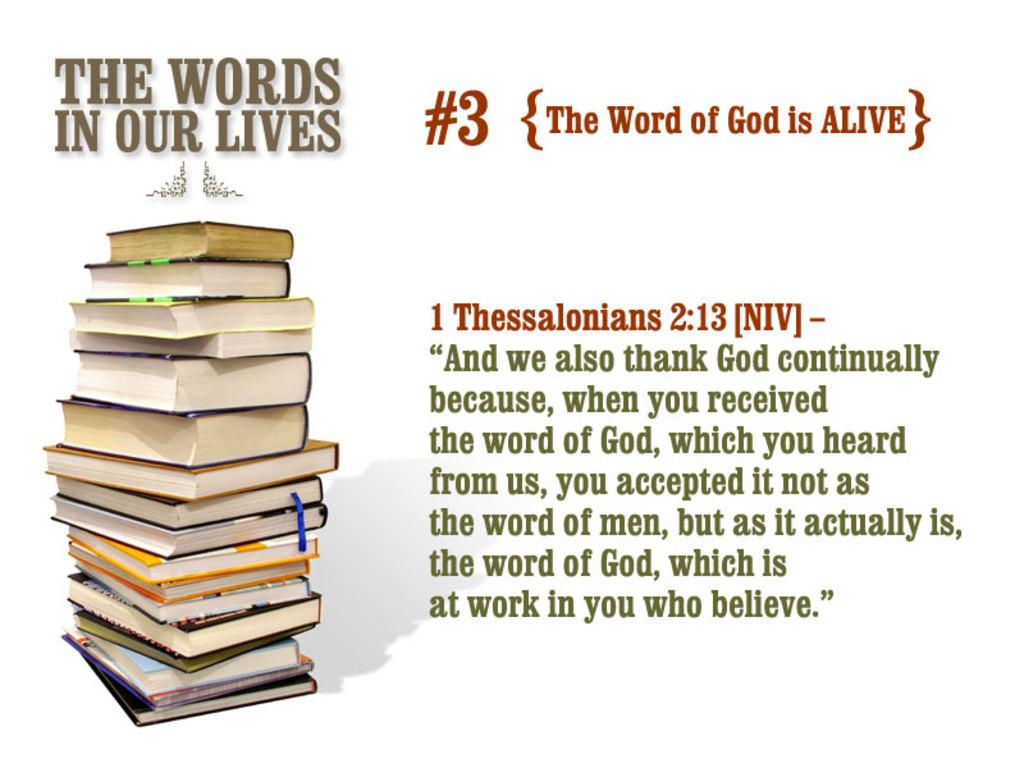<image>
Relay a brief, clear account of the picture shown. A tall stack of books with a Bible quote from Thessalonians on it. 